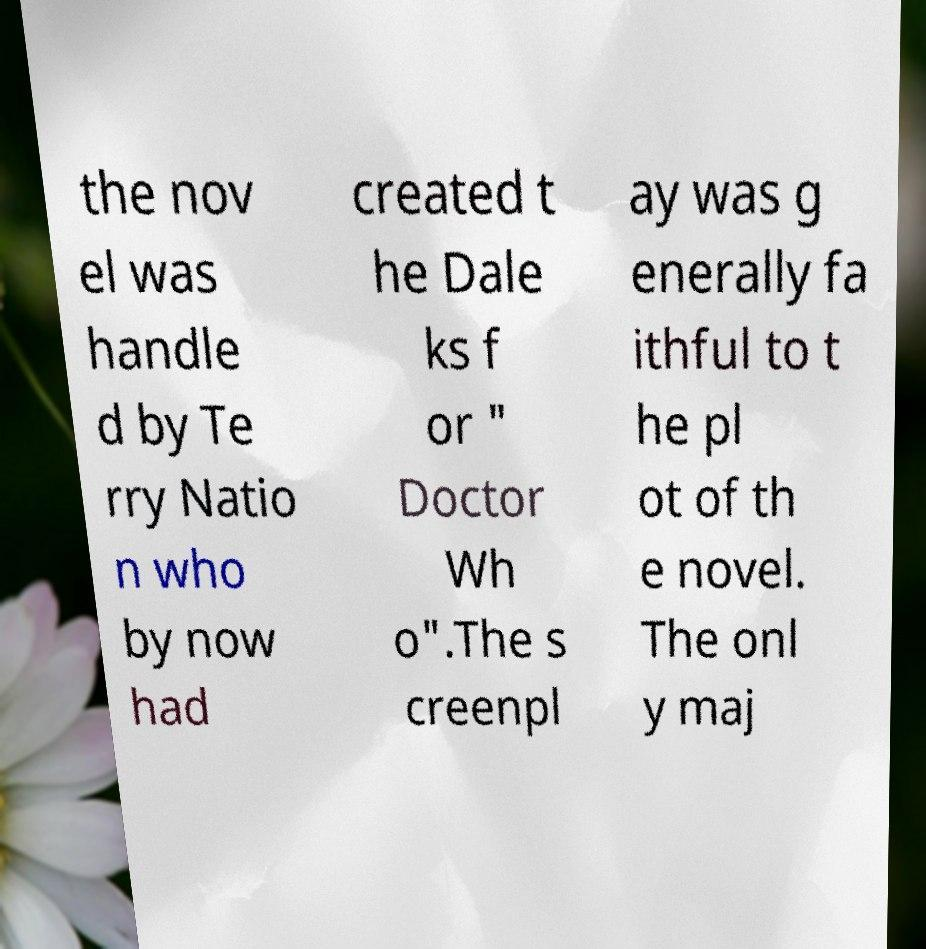Can you accurately transcribe the text from the provided image for me? the nov el was handle d by Te rry Natio n who by now had created t he Dale ks f or " Doctor Wh o".The s creenpl ay was g enerally fa ithful to t he pl ot of th e novel. The onl y maj 